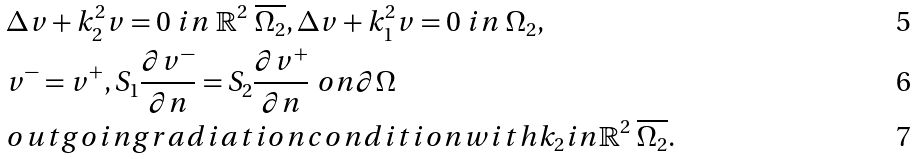Convert formula to latex. <formula><loc_0><loc_0><loc_500><loc_500>& \Delta v + k _ { 2 } ^ { 2 } v = 0 \ i n \ \mathbb { R } ^ { 2 } \ \overline { \Omega _ { 2 } } , \Delta v + k _ { 1 } ^ { 2 } v = 0 \ i n \ { \Omega _ { 2 } } , \\ & v ^ { - } = v ^ { + } , S _ { 1 } \frac { \partial v ^ { - } } { \partial n } = S _ { 2 } \frac { \partial v ^ { + } } { \partial n } \ o n \partial \Omega \\ & o u t g o i n g r a d i a t i o n c o n d i t i o n w i t h k _ { 2 } i n \mathbb { R } ^ { 2 } \ \overline { \Omega _ { 2 } } .</formula> 